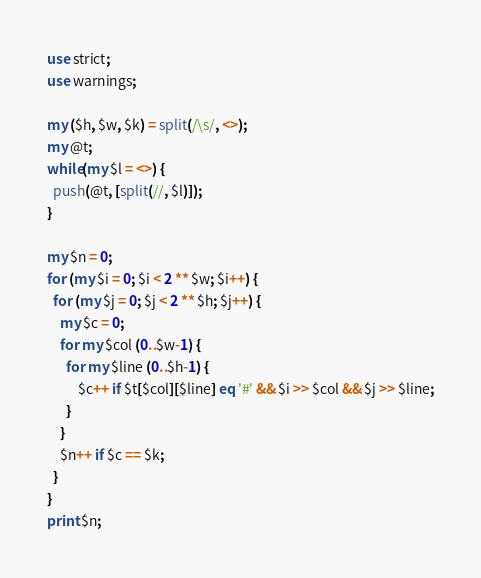Convert code to text. <code><loc_0><loc_0><loc_500><loc_500><_Perl_>use strict;
use warnings;

my ($h, $w, $k) = split(/\s/, <>);
my @t;
while(my $l = <>) {
  push(@t, [split(//, $l)]);
}

my $n = 0;
for (my $i = 0; $i < 2 ** $w; $i++) {
  for (my $j = 0; $j < 2 ** $h; $j++) {
    my $c = 0;
    for my $col (0..$w-1) {
      for my $line (0..$h-1) {
          $c++ if $t[$col][$line] eq '#' && $i >> $col && $j >> $line;
      }
    }
    $n++ if $c == $k;
  }
}
print $n;
</code> 